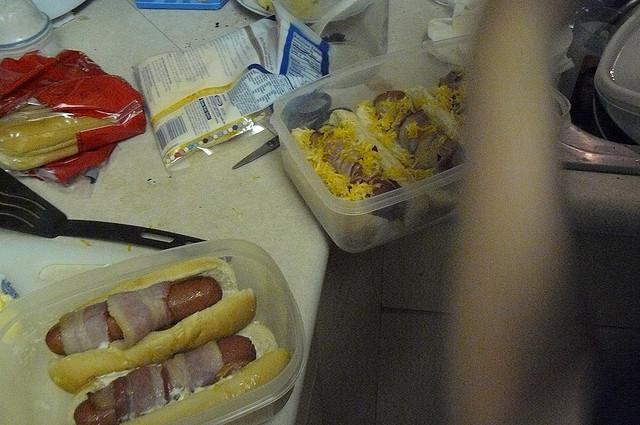How many bowls are visible?
Give a very brief answer. 3. How many hot dogs are there?
Give a very brief answer. 4. 